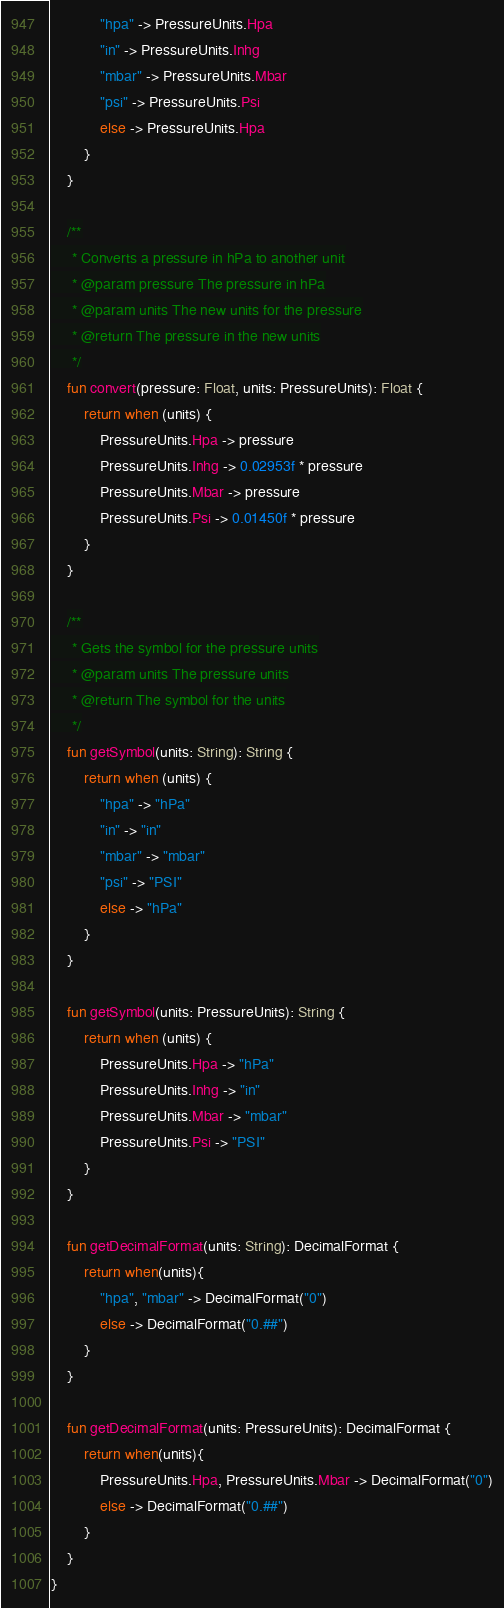<code> <loc_0><loc_0><loc_500><loc_500><_Kotlin_>            "hpa" -> PressureUnits.Hpa
            "in" -> PressureUnits.Inhg
            "mbar" -> PressureUnits.Mbar
            "psi" -> PressureUnits.Psi
            else -> PressureUnits.Hpa
        }
    }

    /**
     * Converts a pressure in hPa to another unit
     * @param pressure The pressure in hPa
     * @param units The new units for the pressure
     * @return The pressure in the new units
     */
    fun convert(pressure: Float, units: PressureUnits): Float {
        return when (units) {
            PressureUnits.Hpa -> pressure
            PressureUnits.Inhg -> 0.02953f * pressure
            PressureUnits.Mbar -> pressure
            PressureUnits.Psi -> 0.01450f * pressure
        }
    }

    /**
     * Gets the symbol for the pressure units
     * @param units The pressure units
     * @return The symbol for the units
     */
    fun getSymbol(units: String): String {
        return when (units) {
            "hpa" -> "hPa"
            "in" -> "in"
            "mbar" -> "mbar"
            "psi" -> "PSI"
            else -> "hPa"
        }
    }

    fun getSymbol(units: PressureUnits): String {
        return when (units) {
            PressureUnits.Hpa -> "hPa"
            PressureUnits.Inhg -> "in"
            PressureUnits.Mbar -> "mbar"
            PressureUnits.Psi -> "PSI"
        }
    }

    fun getDecimalFormat(units: String): DecimalFormat {
        return when(units){
            "hpa", "mbar" -> DecimalFormat("0")
            else -> DecimalFormat("0.##")
        }
    }

    fun getDecimalFormat(units: PressureUnits): DecimalFormat {
        return when(units){
            PressureUnits.Hpa, PressureUnits.Mbar -> DecimalFormat("0")
            else -> DecimalFormat("0.##")
        }
    }
}</code> 